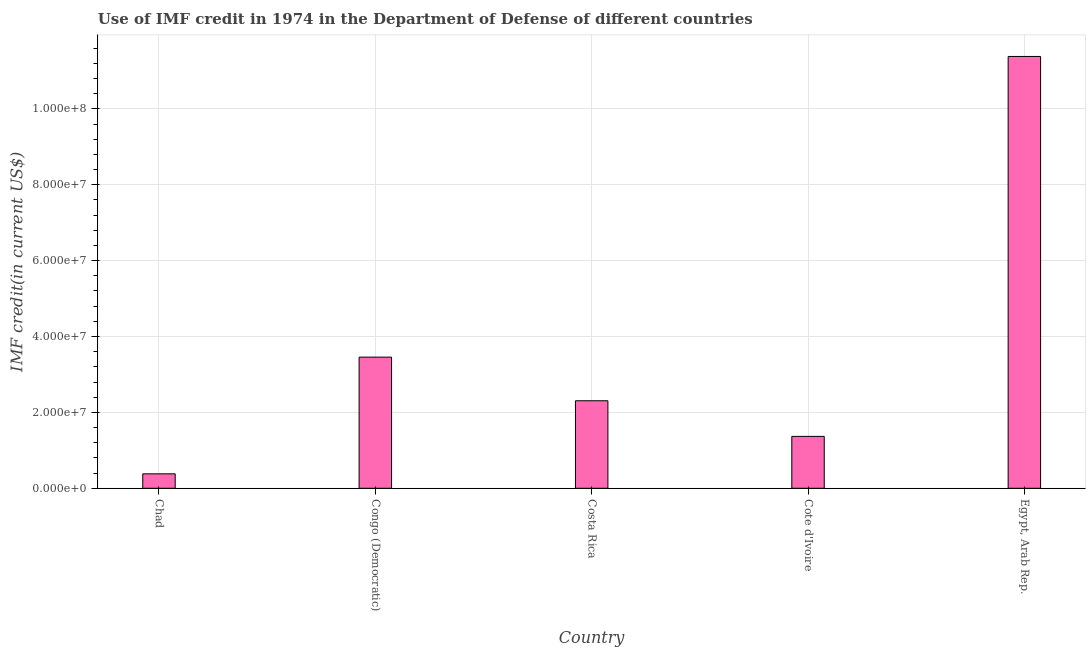Does the graph contain any zero values?
Provide a short and direct response. No. What is the title of the graph?
Your response must be concise. Use of IMF credit in 1974 in the Department of Defense of different countries. What is the label or title of the X-axis?
Give a very brief answer. Country. What is the label or title of the Y-axis?
Ensure brevity in your answer.  IMF credit(in current US$). What is the use of imf credit in dod in Congo (Democratic)?
Provide a short and direct response. 3.46e+07. Across all countries, what is the maximum use of imf credit in dod?
Ensure brevity in your answer.  1.14e+08. Across all countries, what is the minimum use of imf credit in dod?
Offer a terse response. 3.81e+06. In which country was the use of imf credit in dod maximum?
Provide a short and direct response. Egypt, Arab Rep. In which country was the use of imf credit in dod minimum?
Provide a succinct answer. Chad. What is the sum of the use of imf credit in dod?
Offer a terse response. 1.89e+08. What is the difference between the use of imf credit in dod in Congo (Democratic) and Costa Rica?
Provide a succinct answer. 1.15e+07. What is the average use of imf credit in dod per country?
Your answer should be very brief. 3.78e+07. What is the median use of imf credit in dod?
Offer a terse response. 2.31e+07. What is the ratio of the use of imf credit in dod in Costa Rica to that in Egypt, Arab Rep.?
Your answer should be very brief. 0.2. Is the use of imf credit in dod in Costa Rica less than that in Cote d'Ivoire?
Offer a very short reply. No. Is the difference between the use of imf credit in dod in Chad and Cote d'Ivoire greater than the difference between any two countries?
Provide a succinct answer. No. What is the difference between the highest and the second highest use of imf credit in dod?
Your answer should be very brief. 7.92e+07. What is the difference between the highest and the lowest use of imf credit in dod?
Offer a terse response. 1.10e+08. In how many countries, is the use of imf credit in dod greater than the average use of imf credit in dod taken over all countries?
Offer a very short reply. 1. How many bars are there?
Give a very brief answer. 5. Are all the bars in the graph horizontal?
Make the answer very short. No. What is the IMF credit(in current US$) of Chad?
Your answer should be compact. 3.81e+06. What is the IMF credit(in current US$) in Congo (Democratic)?
Provide a succinct answer. 3.46e+07. What is the IMF credit(in current US$) of Costa Rica?
Give a very brief answer. 2.31e+07. What is the IMF credit(in current US$) in Cote d'Ivoire?
Offer a terse response. 1.37e+07. What is the IMF credit(in current US$) of Egypt, Arab Rep.?
Make the answer very short. 1.14e+08. What is the difference between the IMF credit(in current US$) in Chad and Congo (Democratic)?
Your answer should be very brief. -3.08e+07. What is the difference between the IMF credit(in current US$) in Chad and Costa Rica?
Provide a short and direct response. -1.93e+07. What is the difference between the IMF credit(in current US$) in Chad and Cote d'Ivoire?
Ensure brevity in your answer.  -9.87e+06. What is the difference between the IMF credit(in current US$) in Chad and Egypt, Arab Rep.?
Offer a very short reply. -1.10e+08. What is the difference between the IMF credit(in current US$) in Congo (Democratic) and Costa Rica?
Offer a very short reply. 1.15e+07. What is the difference between the IMF credit(in current US$) in Congo (Democratic) and Cote d'Ivoire?
Offer a terse response. 2.09e+07. What is the difference between the IMF credit(in current US$) in Congo (Democratic) and Egypt, Arab Rep.?
Make the answer very short. -7.92e+07. What is the difference between the IMF credit(in current US$) in Costa Rica and Cote d'Ivoire?
Offer a terse response. 9.39e+06. What is the difference between the IMF credit(in current US$) in Costa Rica and Egypt, Arab Rep.?
Offer a very short reply. -9.07e+07. What is the difference between the IMF credit(in current US$) in Cote d'Ivoire and Egypt, Arab Rep.?
Provide a succinct answer. -1.00e+08. What is the ratio of the IMF credit(in current US$) in Chad to that in Congo (Democratic)?
Offer a very short reply. 0.11. What is the ratio of the IMF credit(in current US$) in Chad to that in Costa Rica?
Make the answer very short. 0.17. What is the ratio of the IMF credit(in current US$) in Chad to that in Cote d'Ivoire?
Your answer should be very brief. 0.28. What is the ratio of the IMF credit(in current US$) in Chad to that in Egypt, Arab Rep.?
Your answer should be compact. 0.03. What is the ratio of the IMF credit(in current US$) in Congo (Democratic) to that in Costa Rica?
Provide a short and direct response. 1.5. What is the ratio of the IMF credit(in current US$) in Congo (Democratic) to that in Cote d'Ivoire?
Your answer should be very brief. 2.53. What is the ratio of the IMF credit(in current US$) in Congo (Democratic) to that in Egypt, Arab Rep.?
Make the answer very short. 0.3. What is the ratio of the IMF credit(in current US$) in Costa Rica to that in Cote d'Ivoire?
Your answer should be very brief. 1.69. What is the ratio of the IMF credit(in current US$) in Costa Rica to that in Egypt, Arab Rep.?
Your answer should be very brief. 0.2. What is the ratio of the IMF credit(in current US$) in Cote d'Ivoire to that in Egypt, Arab Rep.?
Make the answer very short. 0.12. 